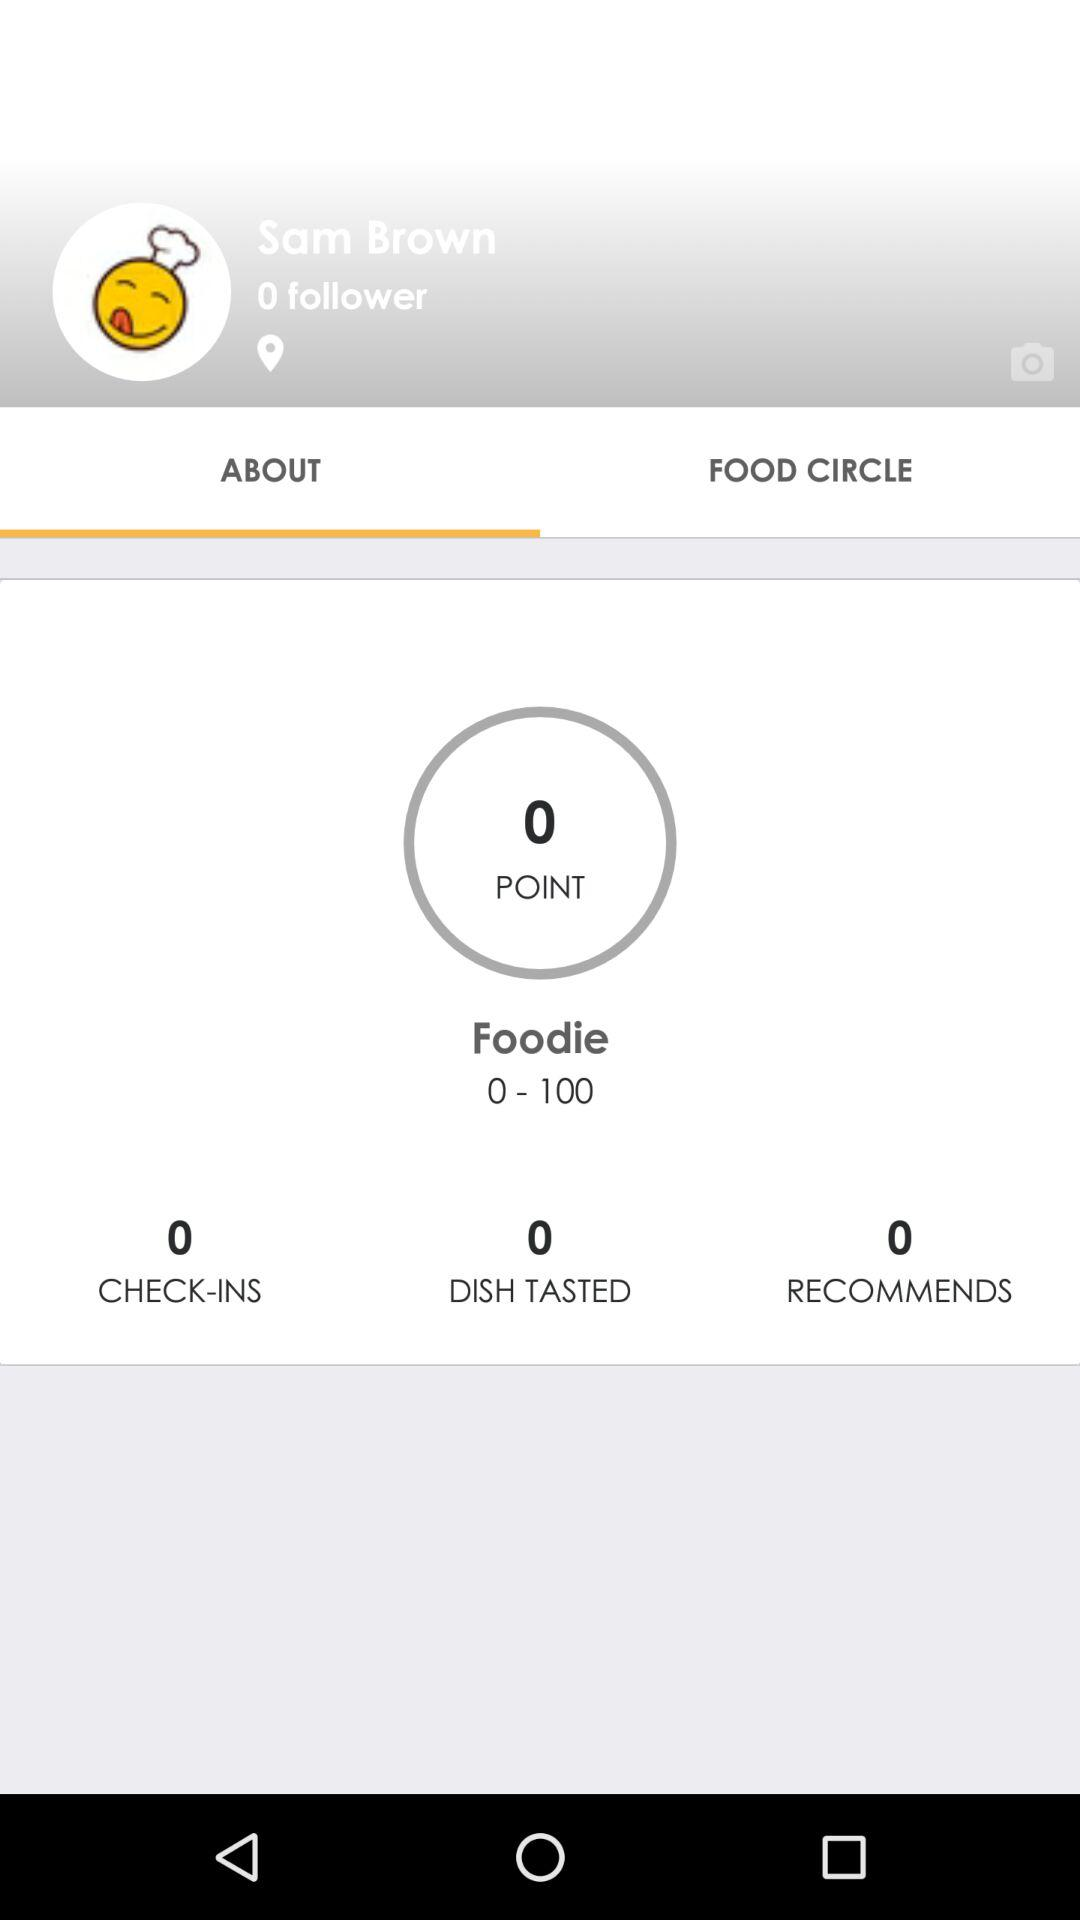How many followers does Sam Brown have?
Answer the question using a single word or phrase. 0 